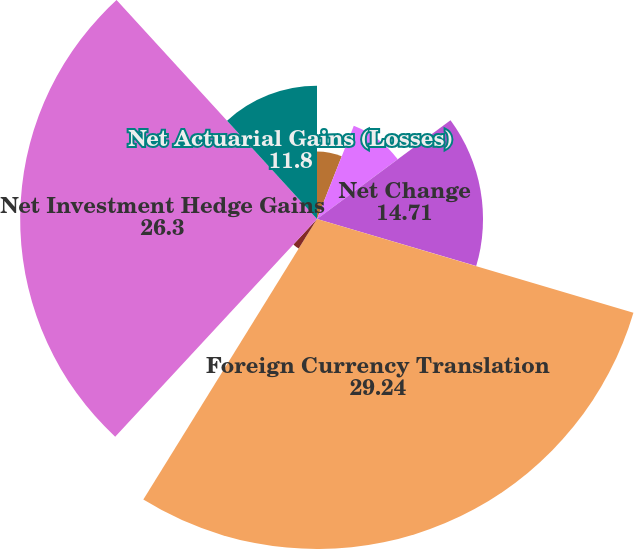Convert chart to OTSL. <chart><loc_0><loc_0><loc_500><loc_500><pie_chart><fcel>Unrealized (Losses) Gains on<fcel>Reclassification Adjustment<fcel>Net Change<fcel>Foreign Currency Translation<fcel>Long-Term Intra-Entity Foreign<fcel>Net Investment Hedge Gains<fcel>Net Actuarial Gains (Losses)<nl><fcel>5.98%<fcel>8.89%<fcel>14.71%<fcel>29.24%<fcel>3.08%<fcel>26.3%<fcel>11.8%<nl></chart> 